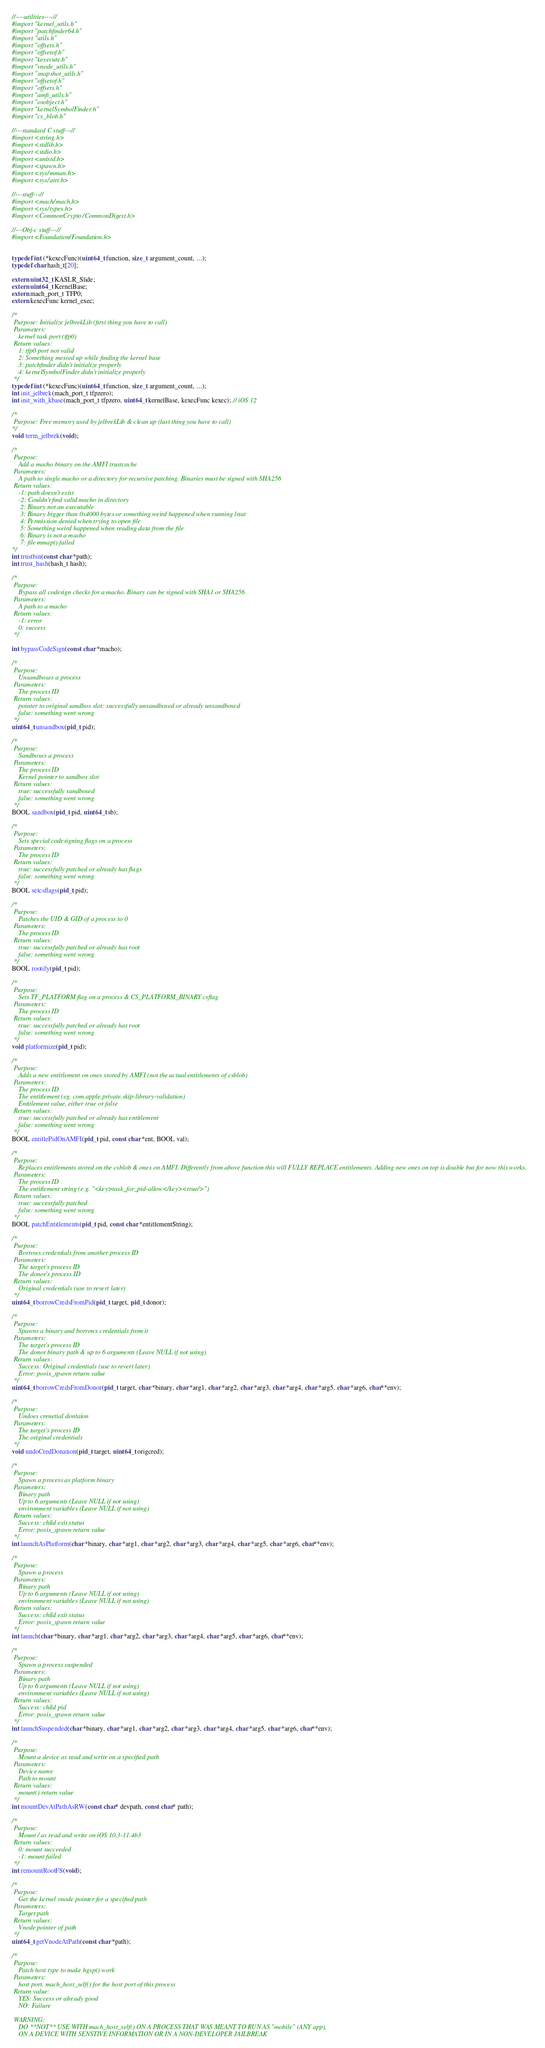<code> <loc_0><loc_0><loc_500><loc_500><_C_>//----utilities----//
#import "kernel_utils.h"
#import "patchfinder64.h"
#import "utils.h"
#import "offsets.h"
#import "offsetof.h"
#import "kexecute.h"
#import "vnode_utils.h"
#import "snapshot_utils.h"
#import "offsetof.h"
#import "offsets.h"
#import "amfi_utils.h"
#import "osobject.h"
#import "kernelSymbolFinder.h"
#import "cs_blob.h"

//---standard C stuff---//
#import <string.h>
#import <stdlib.h>
#import <stdio.h>
#import <unistd.h>
#import <spawn.h>
#import <sys/mman.h>
#import <sys/attr.h>

//---stuff---//
#import <mach/mach.h>
#import <sys/types.h>
#import <CommonCrypto/CommonDigest.h>

//---Obj-c stuff---//
#import <Foundation/Foundation.h>


typedef int (*kexecFunc)(uint64_t function, size_t argument_count, ...);
typedef char hash_t[20];

extern uint32_t KASLR_Slide;
extern uint64_t KernelBase;
extern mach_port_t TFP0;
extern kexecFunc kernel_exec;

/*
 Purpose: Initialize jelbrekLib (first thing you have to call)
 Parameters:
    kernel task port (tfp0)
 Return values:
    1: tfp0 port not valid
    2: Something messed up while finding the kernel base
    3: patchfinder didn't initialize properly
    4: kernelSymbolFinder didn't initialize properly
 */
typedef int (*kexecFunc)(uint64_t function, size_t argument_count, ...);
int init_jelbrek(mach_port_t tfpzero);
int init_with_kbase(mach_port_t tfpzero, uint64_t kernelBase, kexecFunc kexec); // iOS 12

/*
 Purpose: Free memory used by jelbrekLib & clean up (last thing you have to call)
*/
void term_jelbrek(void);

/*
 Purpose:
    Add a macho binary on the AMFI trustcache
 Parameters:
    A path to single macho or a directory for recursive patching. Binaries must be signed with SHA256
 Return values:
    -1: path doesn't exist
    -2: Couldn't find valid macho in directory
     2: Binary not an executable
     3: Binary bigger than 0x4000 bytes or something weird happened when running lstat
     4: Permission denied when trying to open file
     5: Something weird happened when reading data from the file
     6: Binary is not a macho
     7: file mmap() failed
*/
int trustbin(const char *path);
int trust_hash(hash_t hash);

/*
 Purpose:
    Bypass all codesign checks for a macho. Binary can be signed with SHA1 or SHA256
 Parameters:
    A path to a macho
 Return values:
    -1: error
    0: success
 */

int bypassCodeSign(const char *macho);

/*
 Purpose:
    Unsandboxes a process
 Parameters:
    The process ID
 Return values:
    pointer to original sandbox slot: successfully unsandboxed or already unsandboxed
    false: something went wrong
 */
uint64_t unsandbox(pid_t pid);

/*
 Purpose:
    Sandboxes a process
 Parameters:
    The process ID
    Kernel pointer to sandbox slot
 Return values:
    true: successfully sandboxed
    false: something went wrong
 */
BOOL sandbox(pid_t pid, uint64_t sb);

/*
 Purpose:
    Sets special codesigning flags on a process
 Parameters:
    The process ID
 Return values:
    true: successfully patched or already has flags
    false: something went wrong
 */
BOOL setcsflags(pid_t pid);

/*
 Purpose:
    Patches the UID & GID of a process to 0
 Parameters:
    The process ID
 Return values:
    true: successfully patched or already has root
    false: something went wrong
 */
BOOL rootify(pid_t pid);

/*
 Purpose:
    Sets TF_PLATFORM flag on a process & CS_PLATFORM_BINARY csflag
 Parameters:
    The process ID
 Return values:
    true: successfully patched or already has root
    false: something went wrong
 */
void platformize(pid_t pid);

/*
 Purpose:
    Adds a new entitlement on ones stored by AMFI (not the actual entitlements of csblob)
 Parameters:
    The process ID
    The entitlement (eg. com.apple.private.skip-library-validation)
    Entitlement value, either true or false
 Return values:
    true: successfully patched or already has entitlement
    false: something went wrong
 */
BOOL entitlePidOnAMFI(pid_t pid, const char *ent, BOOL val);

/*
 Purpose:
    Replaces entitlements stored on the csblob & ones on AMFI. Differently from above function this will FULLY REPLACE entitlements. Adding new ones on top is doable but for now this works.
 Parameters:
    The process ID
    The entitlement string (e.g. "<key>task_for_pid-allow</key><true/>")
 Return values:
    true: successfully patched
    false: something went wrong
 */
BOOL patchEntitlements(pid_t pid, const char *entitlementString);

/*
 Purpose:
    Borrows credentials from another process ID
 Parameters:
    The target's process ID
    The donor's process ID
 Return values:
    Original credentials (use to revert later)
 */
uint64_t borrowCredsFromPid(pid_t target, pid_t donor);

/*
 Purpose:
    Spawns a binary and borrows credentials from it
 Parameters:
    The target's process ID
    The donor binary path & up to 6 arguments (Leave NULL if not using)
 Return values:
    Success: Original credentials (use to revert later)
    Error: posix_spawn return value
 */
uint64_t borrowCredsFromDonor(pid_t target, char *binary, char *arg1, char *arg2, char *arg3, char *arg4, char *arg5, char *arg6, char**env);

/*
 Purpose:
    Undoes crenetial dontaion
 Parameters:
    The target's process ID
    The original credentials
 */
void undoCredDonation(pid_t target, uint64_t origcred);

/*
 Purpose:
    Spawn a process as platform binary
 Parameters:
    Binary path
    Up to 6 arguments (Leave NULL if not using)
    environment variables (Leave NULL if not using)
 Return values:
    Success: child exit status
    Error: posix_spawn return value
 */
int launchAsPlatform(char *binary, char *arg1, char *arg2, char *arg3, char *arg4, char *arg5, char *arg6, char**env);

/*
 Purpose:
    Spawn a process
 Parameters:
    Binary path
    Up to 6 arguments (Leave NULL if not using)
    environment variables (Leave NULL if not using)
 Return values:
    Success: child exit status
    Error: posix_spawn return value
 */
int launch(char *binary, char *arg1, char *arg2, char *arg3, char *arg4, char *arg5, char *arg6, char**env);

/*
 Purpose:
    Spawn a process suspended
 Parameters:
    Binary path
    Up to 6 arguments (Leave NULL if not using)
    environment variables (Leave NULL if not using)
 Return values:
    Success: child pid
    Error: posix_spawn return value
 */
int launchSuspended(char *binary, char *arg1, char *arg2, char *arg3, char *arg4, char *arg5, char *arg6, char**env);

/*
 Purpose:
    Mount a device as read and write on a specified path
 Parameters:
    Device name
    Path to mount
 Return values:
    mount() return value
 */
int mountDevAtPathAsRW(const char* devpath, const char* path);

/*
 Purpose:
    Mount / as read and write on iOS 10.3-11.4b3
 Return values:
    0: mount succeeded
    -1: mount failed
 */
int remountRootFS(void);

/*
 Purpose:
    Get the kernel vnode pointer for a specified path
 Parameters:
    Target path
 Return values:
    Vnode pointer of path
 */
uint64_t getVnodeAtPath(const char *path);

/*
 Purpose:
    Patch host type to make hgsp() work
 Parameters:
    host port. mach_host_self() for the host port of this process
 Return value:
    YES: Success or already good
    NO: Failure
 
 WARNING:
    DO **NOT** USE WITH mach_host_self() ON A PROCESS THAT WAS MEANT TO RUN AS "mobile" (ANY app),
    ON A DEVICE WITH SENSTIVE INFORMATION OR IN A NON-DEVELOPER JAILBREAK</code> 